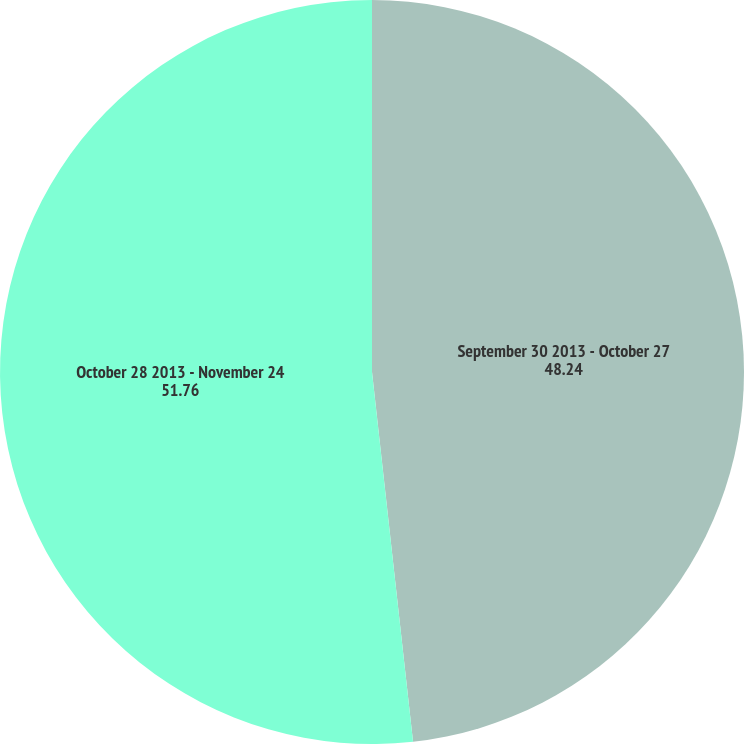Convert chart. <chart><loc_0><loc_0><loc_500><loc_500><pie_chart><fcel>September 30 2013 - October 27<fcel>October 28 2013 - November 24<nl><fcel>48.24%<fcel>51.76%<nl></chart> 